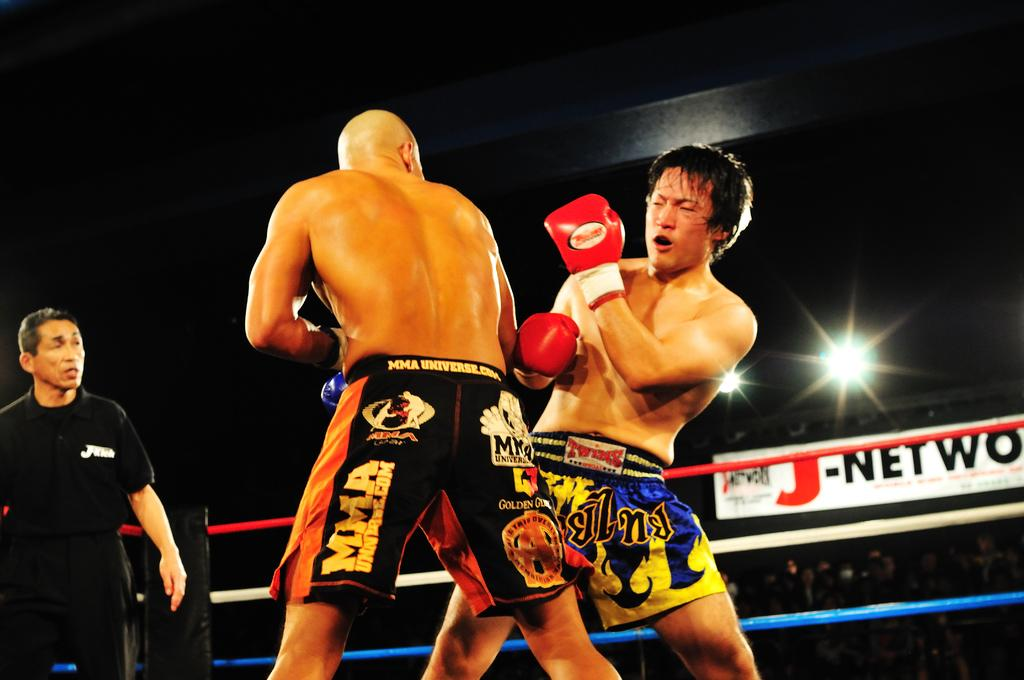<image>
Provide a brief description of the given image. two boxers in a ring in fron of a banner for J-Network 